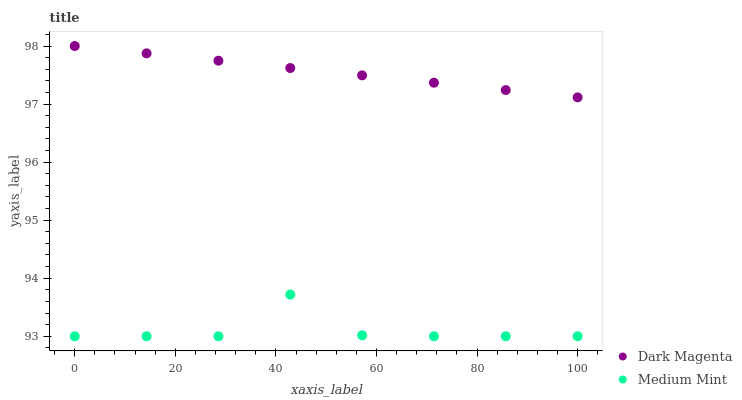Does Medium Mint have the minimum area under the curve?
Answer yes or no. Yes. Does Dark Magenta have the maximum area under the curve?
Answer yes or no. Yes. Does Dark Magenta have the minimum area under the curve?
Answer yes or no. No. Is Dark Magenta the smoothest?
Answer yes or no. Yes. Is Medium Mint the roughest?
Answer yes or no. Yes. Is Dark Magenta the roughest?
Answer yes or no. No. Does Medium Mint have the lowest value?
Answer yes or no. Yes. Does Dark Magenta have the lowest value?
Answer yes or no. No. Does Dark Magenta have the highest value?
Answer yes or no. Yes. Is Medium Mint less than Dark Magenta?
Answer yes or no. Yes. Is Dark Magenta greater than Medium Mint?
Answer yes or no. Yes. Does Medium Mint intersect Dark Magenta?
Answer yes or no. No. 